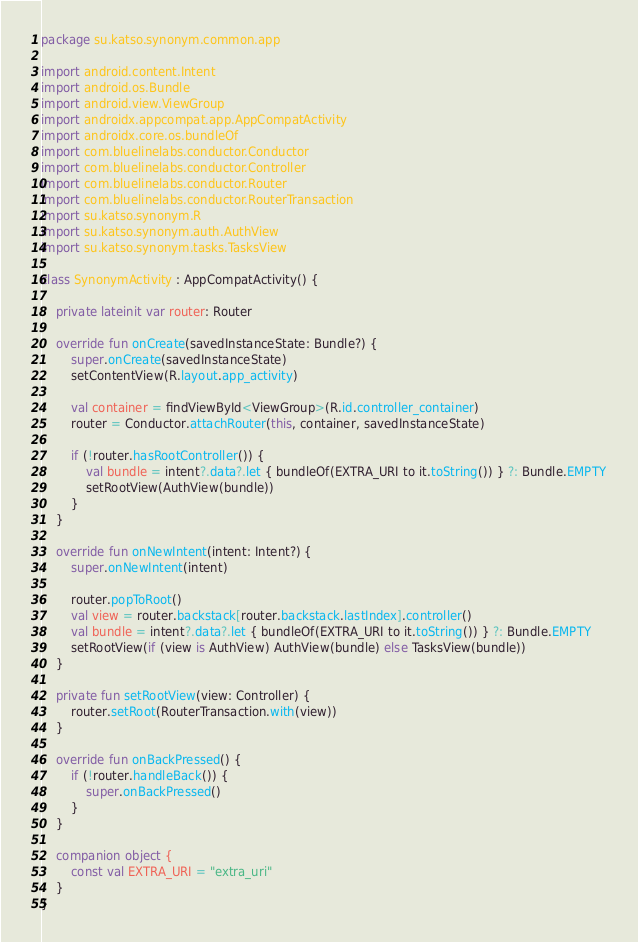Convert code to text. <code><loc_0><loc_0><loc_500><loc_500><_Kotlin_>package su.katso.synonym.common.app

import android.content.Intent
import android.os.Bundle
import android.view.ViewGroup
import androidx.appcompat.app.AppCompatActivity
import androidx.core.os.bundleOf
import com.bluelinelabs.conductor.Conductor
import com.bluelinelabs.conductor.Controller
import com.bluelinelabs.conductor.Router
import com.bluelinelabs.conductor.RouterTransaction
import su.katso.synonym.R
import su.katso.synonym.auth.AuthView
import su.katso.synonym.tasks.TasksView

class SynonymActivity : AppCompatActivity() {

    private lateinit var router: Router

    override fun onCreate(savedInstanceState: Bundle?) {
        super.onCreate(savedInstanceState)
        setContentView(R.layout.app_activity)

        val container = findViewById<ViewGroup>(R.id.controller_container)
        router = Conductor.attachRouter(this, container, savedInstanceState)

        if (!router.hasRootController()) {
            val bundle = intent?.data?.let { bundleOf(EXTRA_URI to it.toString()) } ?: Bundle.EMPTY
            setRootView(AuthView(bundle))
        }
    }

    override fun onNewIntent(intent: Intent?) {
        super.onNewIntent(intent)

        router.popToRoot()
        val view = router.backstack[router.backstack.lastIndex].controller()
        val bundle = intent?.data?.let { bundleOf(EXTRA_URI to it.toString()) } ?: Bundle.EMPTY
        setRootView(if (view is AuthView) AuthView(bundle) else TasksView(bundle))
    }

    private fun setRootView(view: Controller) {
        router.setRoot(RouterTransaction.with(view))
    }

    override fun onBackPressed() {
        if (!router.handleBack()) {
            super.onBackPressed()
        }
    }

    companion object {
        const val EXTRA_URI = "extra_uri"
    }
}
</code> 